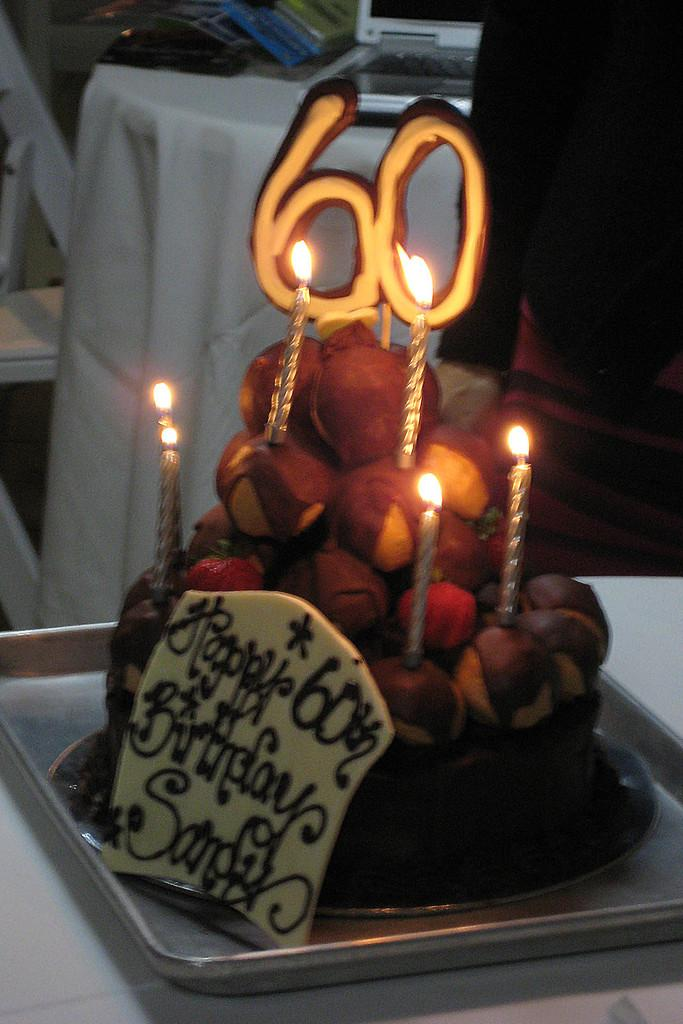What is the main subject of the image? There is a cake in the image. What is written on the cake? The cake has "60" written on it. Are there any decorations on the cake? Yes, there are lit candles on the cake. What can be seen in the background of the image? There is a table in the background of the image. What is on the table in the background? There is a laptop on the table. What type of scent can be smelled coming from the cake in the image? There is no information about the scent of the cake in the image, so it cannot be determined. 